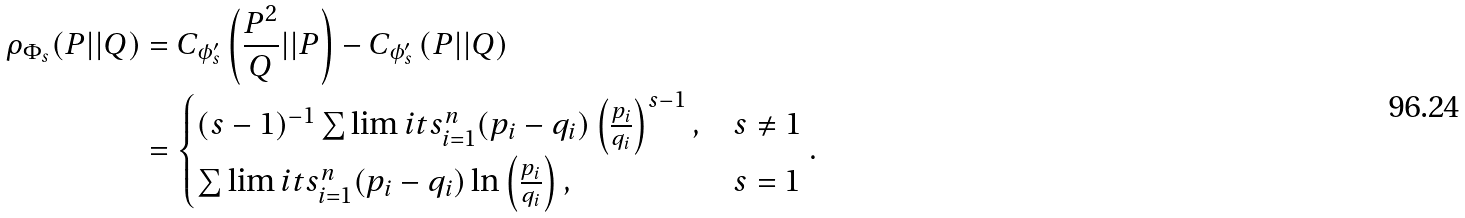<formula> <loc_0><loc_0><loc_500><loc_500>\rho _ { \Phi _ { s } } ( P | | Q ) & = C _ { \phi _ { s } ^ { \prime } } \left ( { \frac { P ^ { 2 } } { Q } | | P } \right ) - C _ { \phi _ { s } ^ { \prime } } \left ( { P | | Q } \right ) \\ & = \begin{cases} { ( s - 1 ) ^ { - 1 } \sum \lim i t s _ { i = 1 } ^ { n } { ( p _ { i } - q _ { i } ) \left ( { \frac { p _ { i } } { q _ { i } } } \right ) ^ { s - 1 } , } } & { s \ne 1 } \\ { \sum \lim i t s _ { i = 1 } ^ { n } { ( p _ { i } - q _ { i } ) \ln \left ( { \frac { p _ { i } } { q _ { i } } } \right ) , } } & { s = 1 } \\ \end{cases} .</formula> 